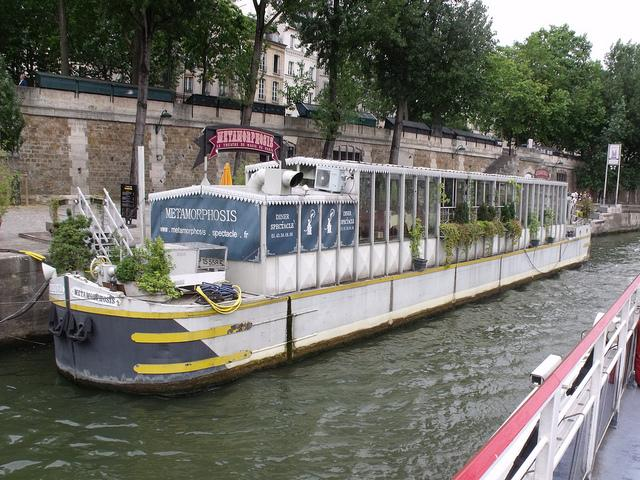Who wrote a book whose title matches the word at the front top of the boat? franz kafka 